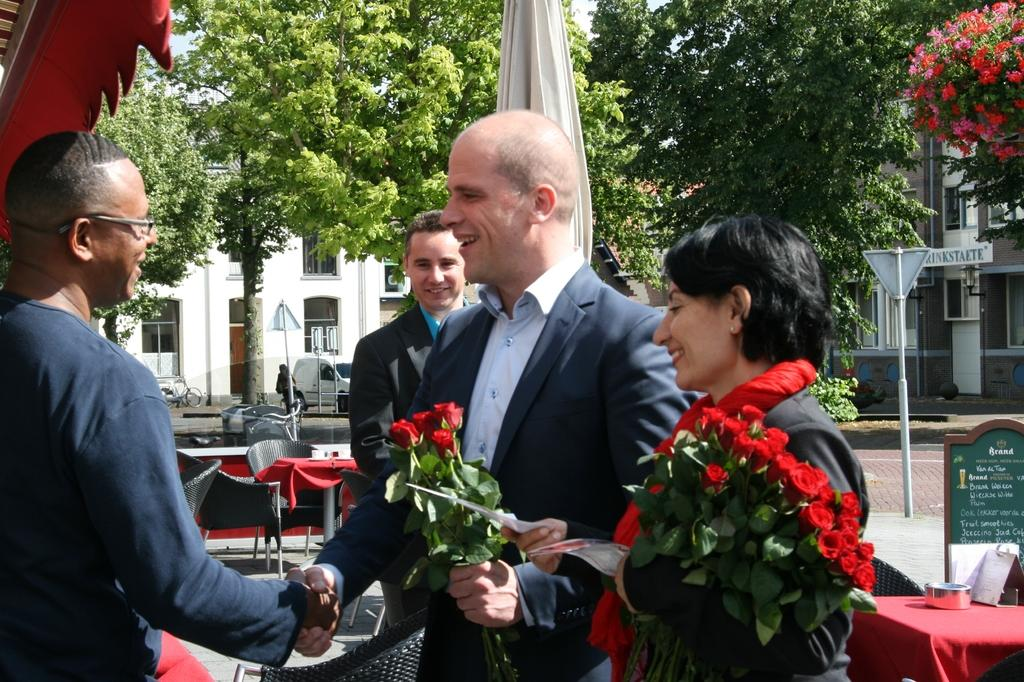Who is the man in the image interacting with? The man is shaking hands with a woman. What is the woman's role in the image? The woman is the other person involved in the handshake. What can be seen in the background of the image? There are trees and buildings in the background of the image. What time of day does the beginner start their morning routine in the image? There is no indication of a morning routine or a beginner in the image; it simply shows a man shaking hands with a woman. 